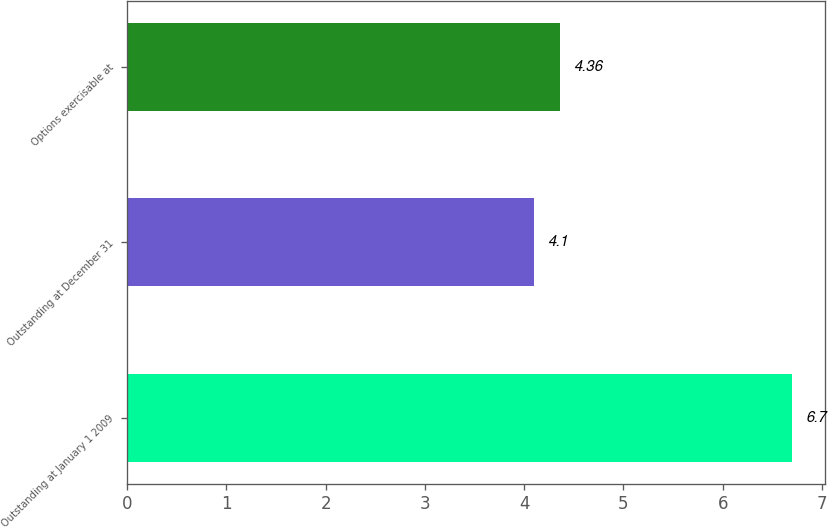Convert chart. <chart><loc_0><loc_0><loc_500><loc_500><bar_chart><fcel>Outstanding at January 1 2009<fcel>Outstanding at December 31<fcel>Options exercisable at<nl><fcel>6.7<fcel>4.1<fcel>4.36<nl></chart> 